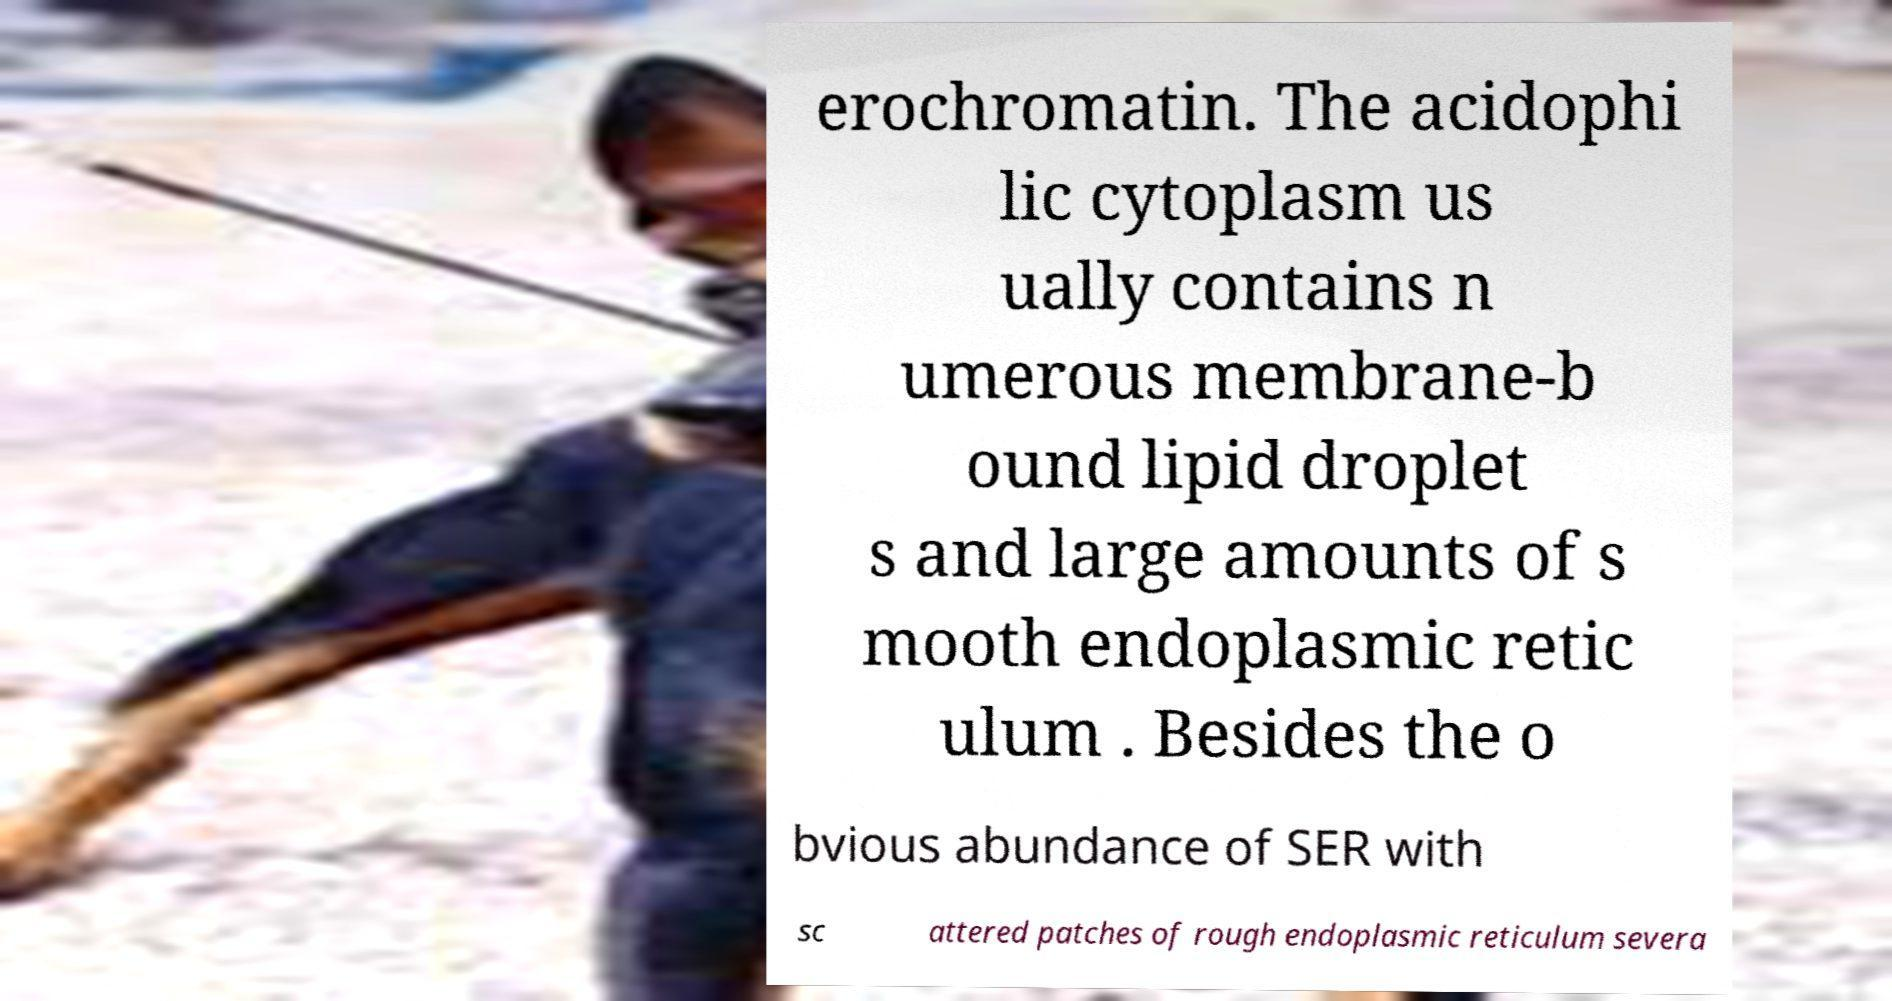There's text embedded in this image that I need extracted. Can you transcribe it verbatim? erochromatin. The acidophi lic cytoplasm us ually contains n umerous membrane-b ound lipid droplet s and large amounts of s mooth endoplasmic retic ulum . Besides the o bvious abundance of SER with sc attered patches of rough endoplasmic reticulum severa 